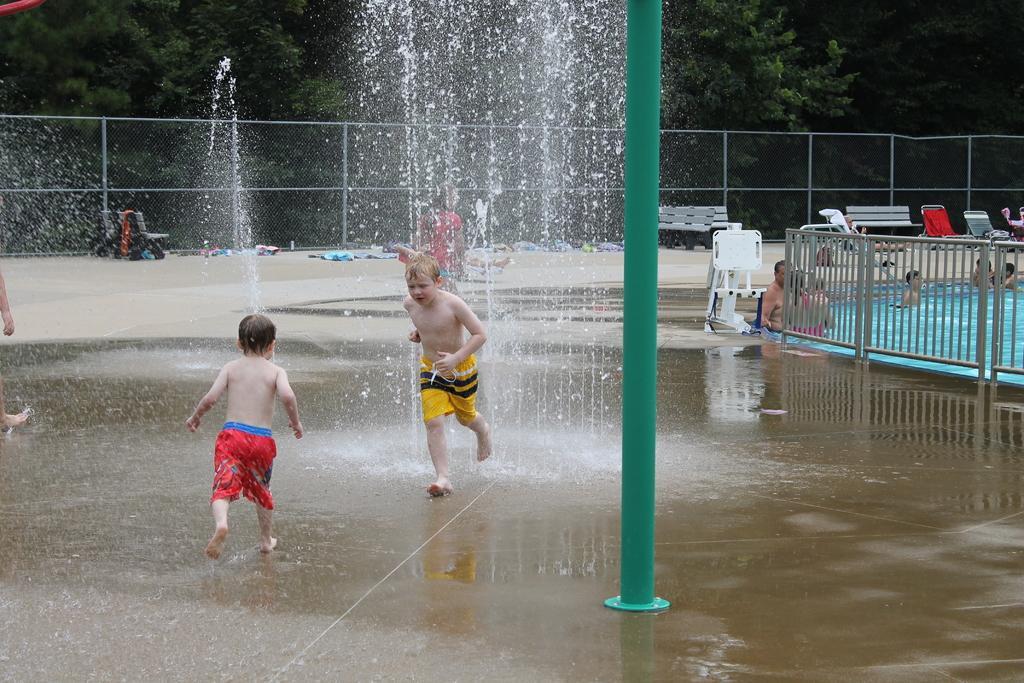Can you describe this image briefly? In this image, we can see two kids in front of the fountain. There is a pole in the middle of the image. There is a barricade in front of the swimming pool contains some persons. In the background of the image, there are some trees. 